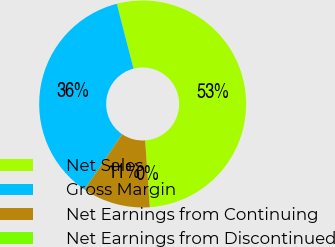<chart> <loc_0><loc_0><loc_500><loc_500><pie_chart><fcel>Net Sales<fcel>Gross Margin<fcel>Net Earnings from Continuing<fcel>Net Earnings from Discontinued<nl><fcel>52.92%<fcel>36.49%<fcel>10.58%<fcel>0.0%<nl></chart> 